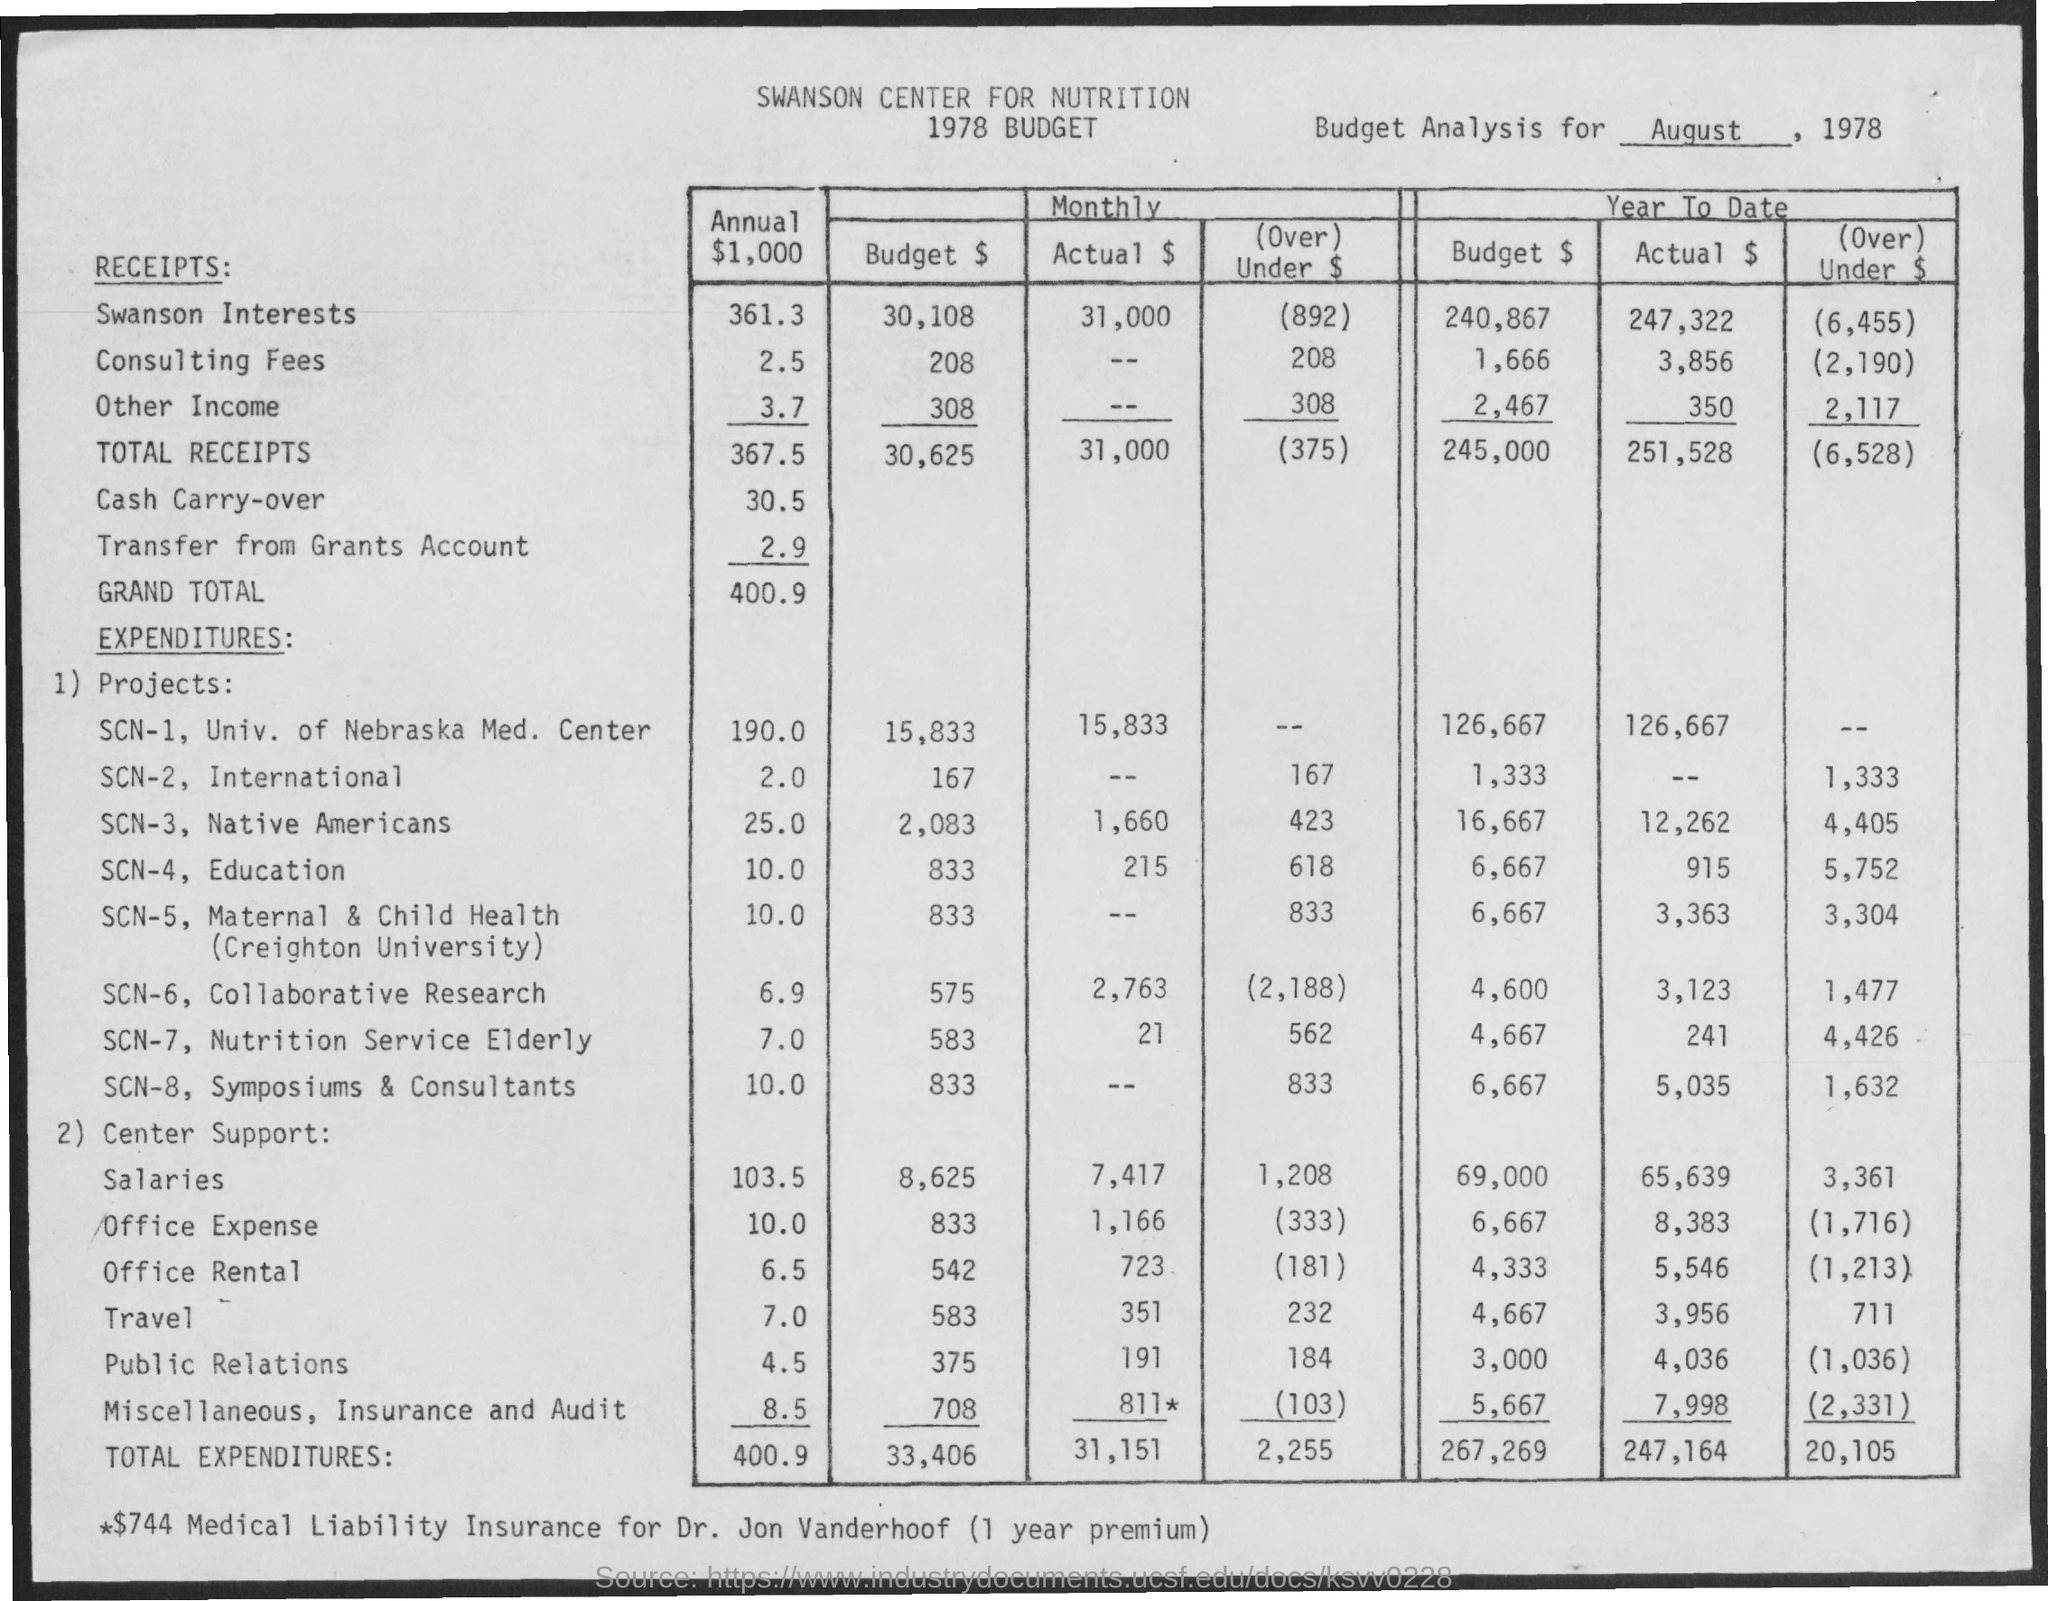What is the date mentioned in the given page ?
Ensure brevity in your answer.  August , 1978. What is the annual value of total receipts mentioned ?
Give a very brief answer. 367.5. What is the annual grand total mentioned ?
Your answer should be very brief. 400.9. What is the value of annual total expenditures ?
Your answer should be compact. 400.9. What is the actual amount of total expenditures monthly ?
Provide a succinct answer. 31,151. 